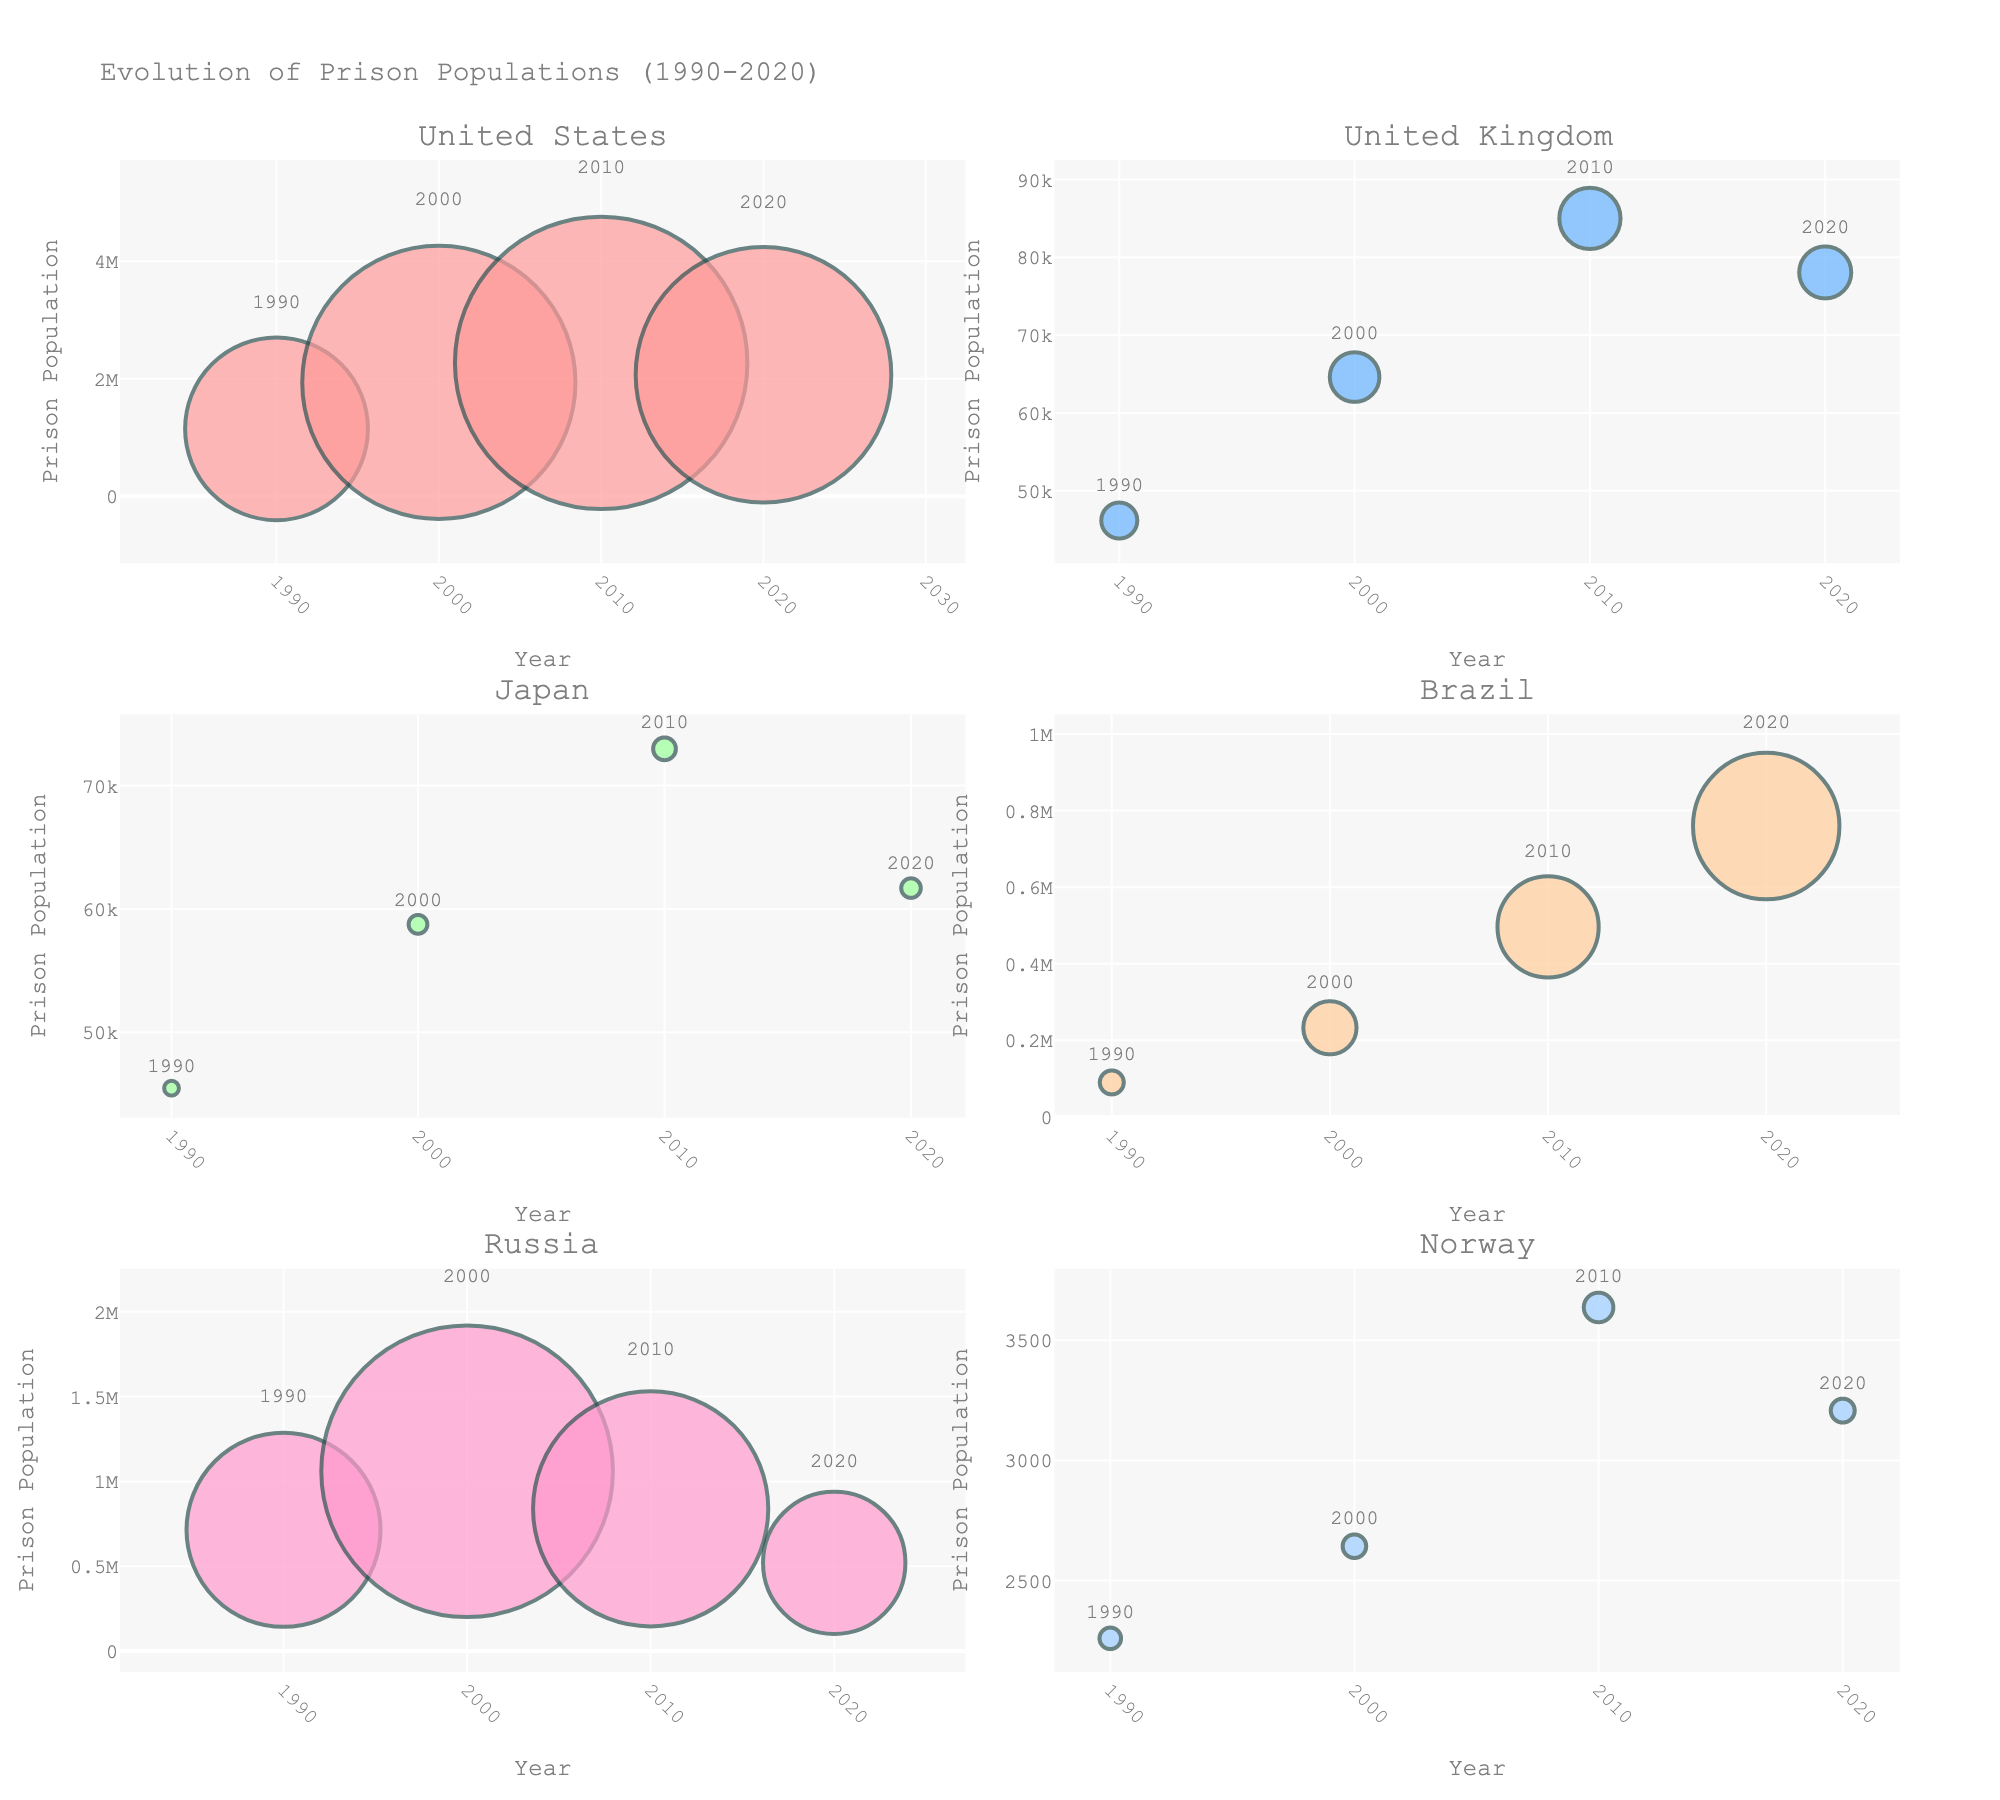How many players are shown in the scatter plot? Count the number of data points in the scatter plot. Each point represents a player.
Answer: 20 What are the labels of the axes in the scatter plot? The scatter plot has labels on the x-axis and y-axis. The x-axis is labeled "Catch Radius (inches)" and the y-axis is labeled "Yards After Catch."
Answer: Catch Radius (inches) and Yards After Catch Which player has the highest Yards After Catch? Identify the data point that is highest on the y-axis. The player's name should be displayed next to the point.
Answer: Rondale Moore What is the title of the subplot on the right? Look at the title displayed above the right subplot.
Answer: Player Rankings Who has a higher catch radius, Ja'Marr Chase or DeVonta Smith? Locate the data points for both players in the scatter plot and compare their x-axis positions.
Answer: Ja'Marr Chase What is the overall ranking of Rondale Moore? Check the bar plot on the right subplot. Find the bar labeled "Rondale Moore" and note its position on the y-axis, which represents the overall rank.
Answer: Not shown on Y-axis with value Find the player with the smallest catch radius and determine their Yards After Catch. Identify the data point with the lowest value on the x-axis, which corresponds to the smallest catch radius. Then look at its position on the y-axis to find the Yards After Catch.
Answer: Rondale Moore, 8.1 Compare the catch radius of Nico Collins and Simi Fehoko. Who has a larger catch radius? Locate the data points for both players in the scatter plot and compare their positions on the x-axis. The player farther to the right has the larger catch radius.
Answer: Simi Fehoko Which player appears to be ranked highest in the overall ranking based on the bar plot? In the bar plot on the right subplot, the bar closest to the top represents the highest overall ranking. Identify the player associated with this bar.
Answer: Not shown on Y-axis with value Who is ranked lower, Anthony Schwartz or Dazz Newsome? Refer to the bar plot and locate the bars for Anthony Schwartz and Dazz Newsome. The player with a bar positioned lower on the y-axis has a lower overall ranking.
Answer: Not shown on Y-axis with value 